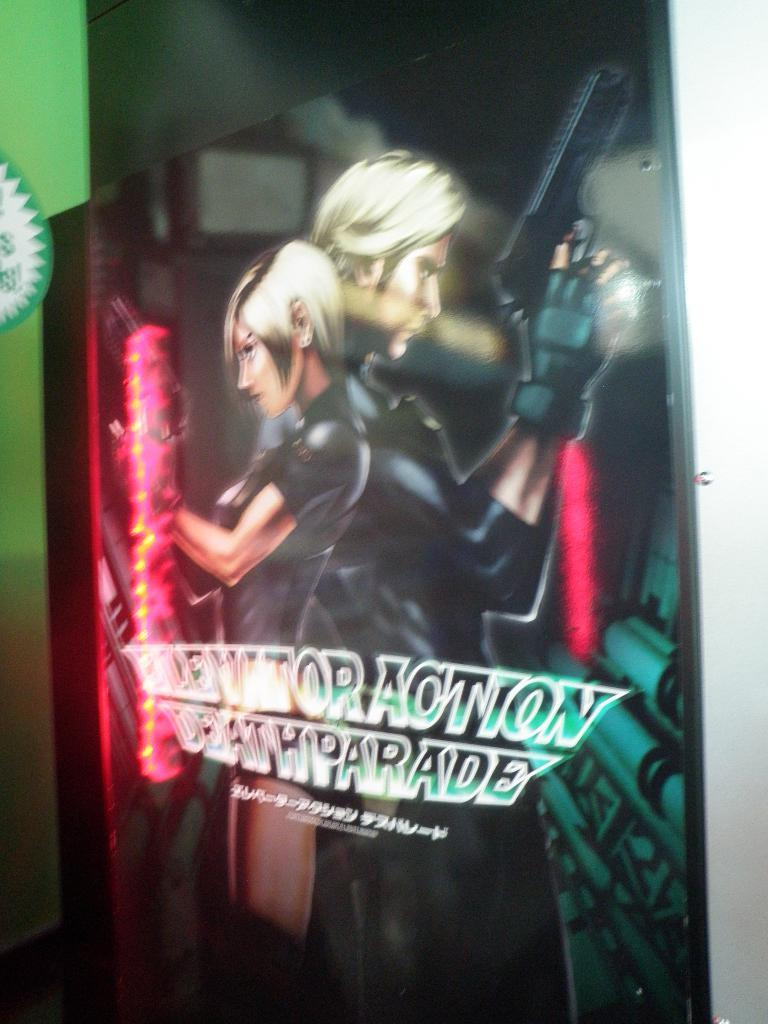What is the main subject of the image? The main subject of the image is a poster. What characters are featured on the poster? The poster features a cartoon man and a woman. What are the man and woman holding in the image? The man and woman are depicted with guns. Is there any text or name on the poster? Yes, there is a name or text on the poster. Can you see any airplane in the image? No, there is no airplane present in the image. What kind of trouble are the man and woman causing in the image? The image does not depict any trouble or conflict; it only shows the man and woman holding guns. 